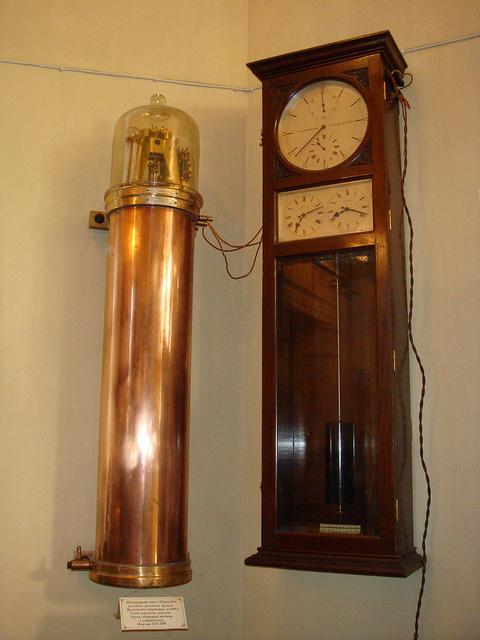Is this a grandfather clock?
Quick response, please. Yes. What is the object on the right?
Quick response, please. Clock. Could these items be in a museum?
Concise answer only. Yes. 